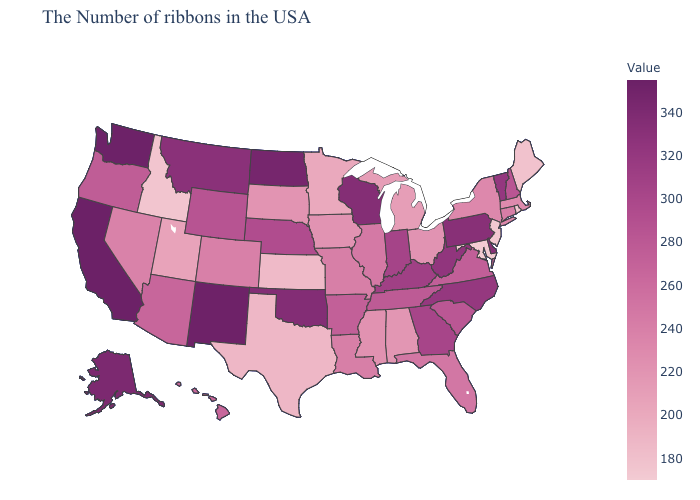Among the states that border West Virginia , does Ohio have the lowest value?
Quick response, please. No. Which states have the lowest value in the USA?
Concise answer only. Maryland. Among the states that border Montana , which have the highest value?
Short answer required. North Dakota. Which states have the highest value in the USA?
Keep it brief. California. Among the states that border Georgia , which have the highest value?
Quick response, please. North Carolina. Among the states that border Utah , does New Mexico have the lowest value?
Give a very brief answer. No. Is the legend a continuous bar?
Short answer required. Yes. 